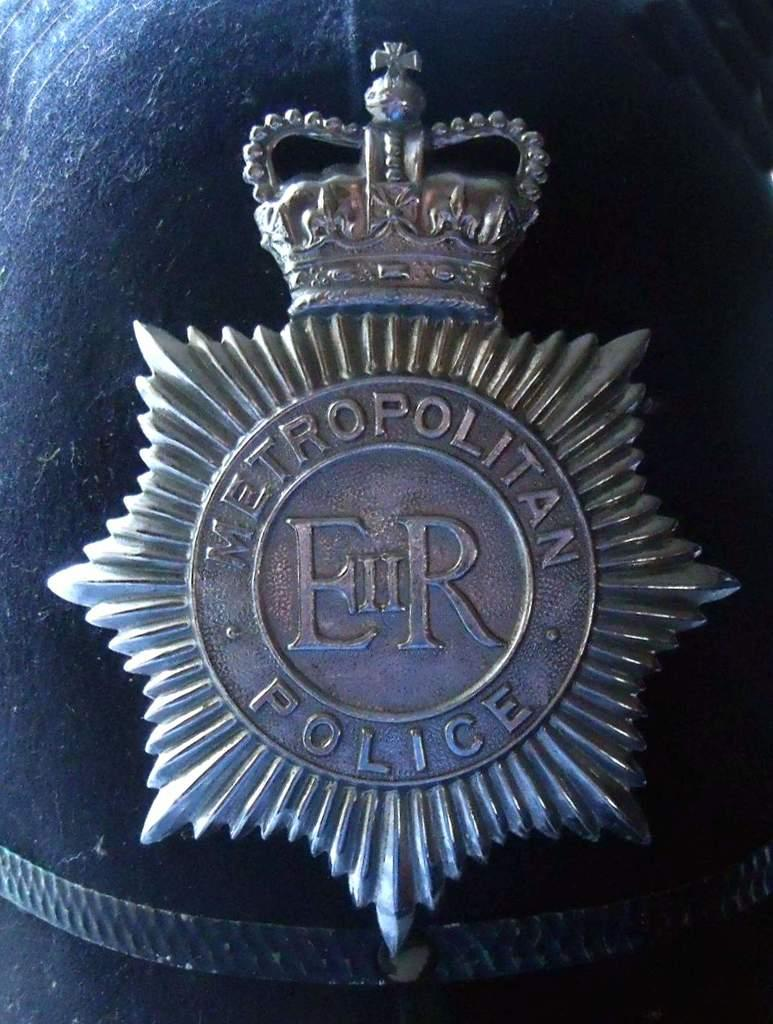<image>
Offer a succinct explanation of the picture presented. A badge for the Metropolitan police department, with a crown on the top of it. 